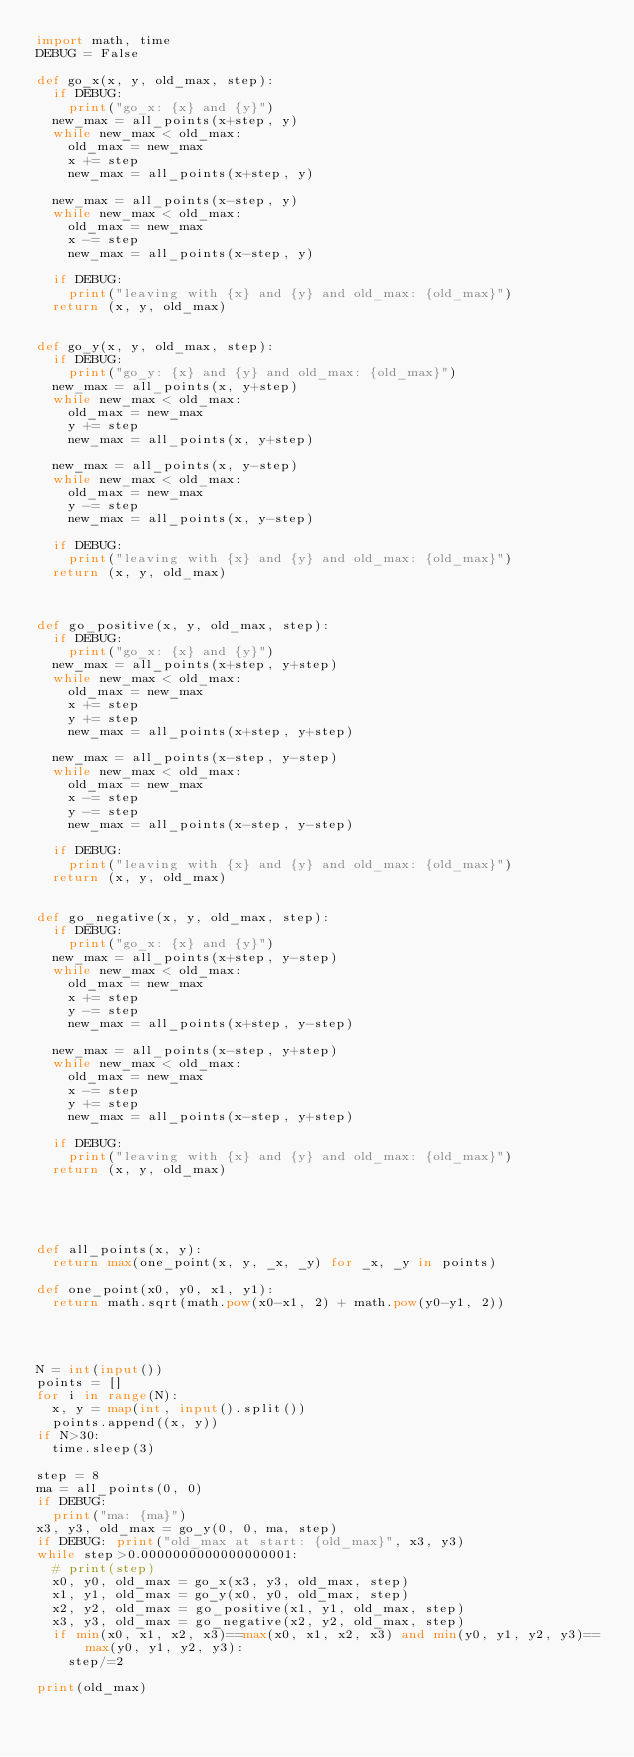<code> <loc_0><loc_0><loc_500><loc_500><_Python_>import math, time
DEBUG = False

def go_x(x, y, old_max, step):
	if DEBUG:
		print("go_x: {x} and {y}")
	new_max = all_points(x+step, y)
	while new_max < old_max:
		old_max = new_max
		x += step
		new_max = all_points(x+step, y)

	new_max = all_points(x-step, y)
	while new_max < old_max:
		old_max = new_max
		x -= step
		new_max = all_points(x-step, y)
	
	if DEBUG:
		print("leaving with {x} and {y} and old_max: {old_max}")
	return (x, y, old_max)


def go_y(x, y, old_max, step):
	if DEBUG:
		print("go_y: {x} and {y} and old_max: {old_max}")
	new_max = all_points(x, y+step)
	while new_max < old_max:
		old_max = new_max
		y += step
		new_max = all_points(x, y+step)

	new_max = all_points(x, y-step)
	while new_max < old_max:
		old_max = new_max
		y -= step
		new_max = all_points(x, y-step)

	if DEBUG:
		print("leaving with {x} and {y} and old_max: {old_max}")
	return (x, y, old_max)



def go_positive(x, y, old_max, step):
	if DEBUG:
		print("go_x: {x} and {y}")
	new_max = all_points(x+step, y+step)
	while new_max < old_max:
		old_max = new_max
		x += step
		y += step
		new_max = all_points(x+step, y+step)

	new_max = all_points(x-step, y-step)
	while new_max < old_max:
		old_max = new_max
		x -= step
		y -= step
		new_max = all_points(x-step, y-step)
	
	if DEBUG:
		print("leaving with {x} and {y} and old_max: {old_max}")
	return (x, y, old_max)


def go_negative(x, y, old_max, step):
	if DEBUG:
		print("go_x: {x} and {y}")
	new_max = all_points(x+step, y-step)
	while new_max < old_max:
		old_max = new_max
		x += step
		y -= step
		new_max = all_points(x+step, y-step)

	new_max = all_points(x-step, y+step)
	while new_max < old_max:
		old_max = new_max
		x -= step
		y += step
		new_max = all_points(x-step, y+step)
	
	if DEBUG:
		print("leaving with {x} and {y} and old_max: {old_max}")
	return (x, y, old_max)





def all_points(x, y):
	return max(one_point(x, y, _x, _y) for _x, _y in points)

def one_point(x0, y0, x1, y1):
	return math.sqrt(math.pow(x0-x1, 2) + math.pow(y0-y1, 2))




N = int(input())
points = []
for i in range(N):
	x, y = map(int, input().split())
	points.append((x, y))
if N>30:
	time.sleep(3)

step = 8
ma = all_points(0, 0)
if DEBUG:
	print("ma: {ma}")
x3, y3, old_max = go_y(0, 0, ma, step)
if DEBUG: print("old_max at start: {old_max}", x3, y3)
while step>0.0000000000000000001:
	# print(step)
	x0, y0, old_max = go_x(x3, y3, old_max, step)
	x1, y1, old_max = go_y(x0, y0, old_max, step)
	x2, y2, old_max = go_positive(x1, y1, old_max, step)
	x3, y3, old_max = go_negative(x2, y2, old_max, step)
	if min(x0, x1, x2, x3)==max(x0, x1, x2, x3) and min(y0, y1, y2, y3)==max(y0, y1, y2, y3):
		step/=2

print(old_max)


</code> 